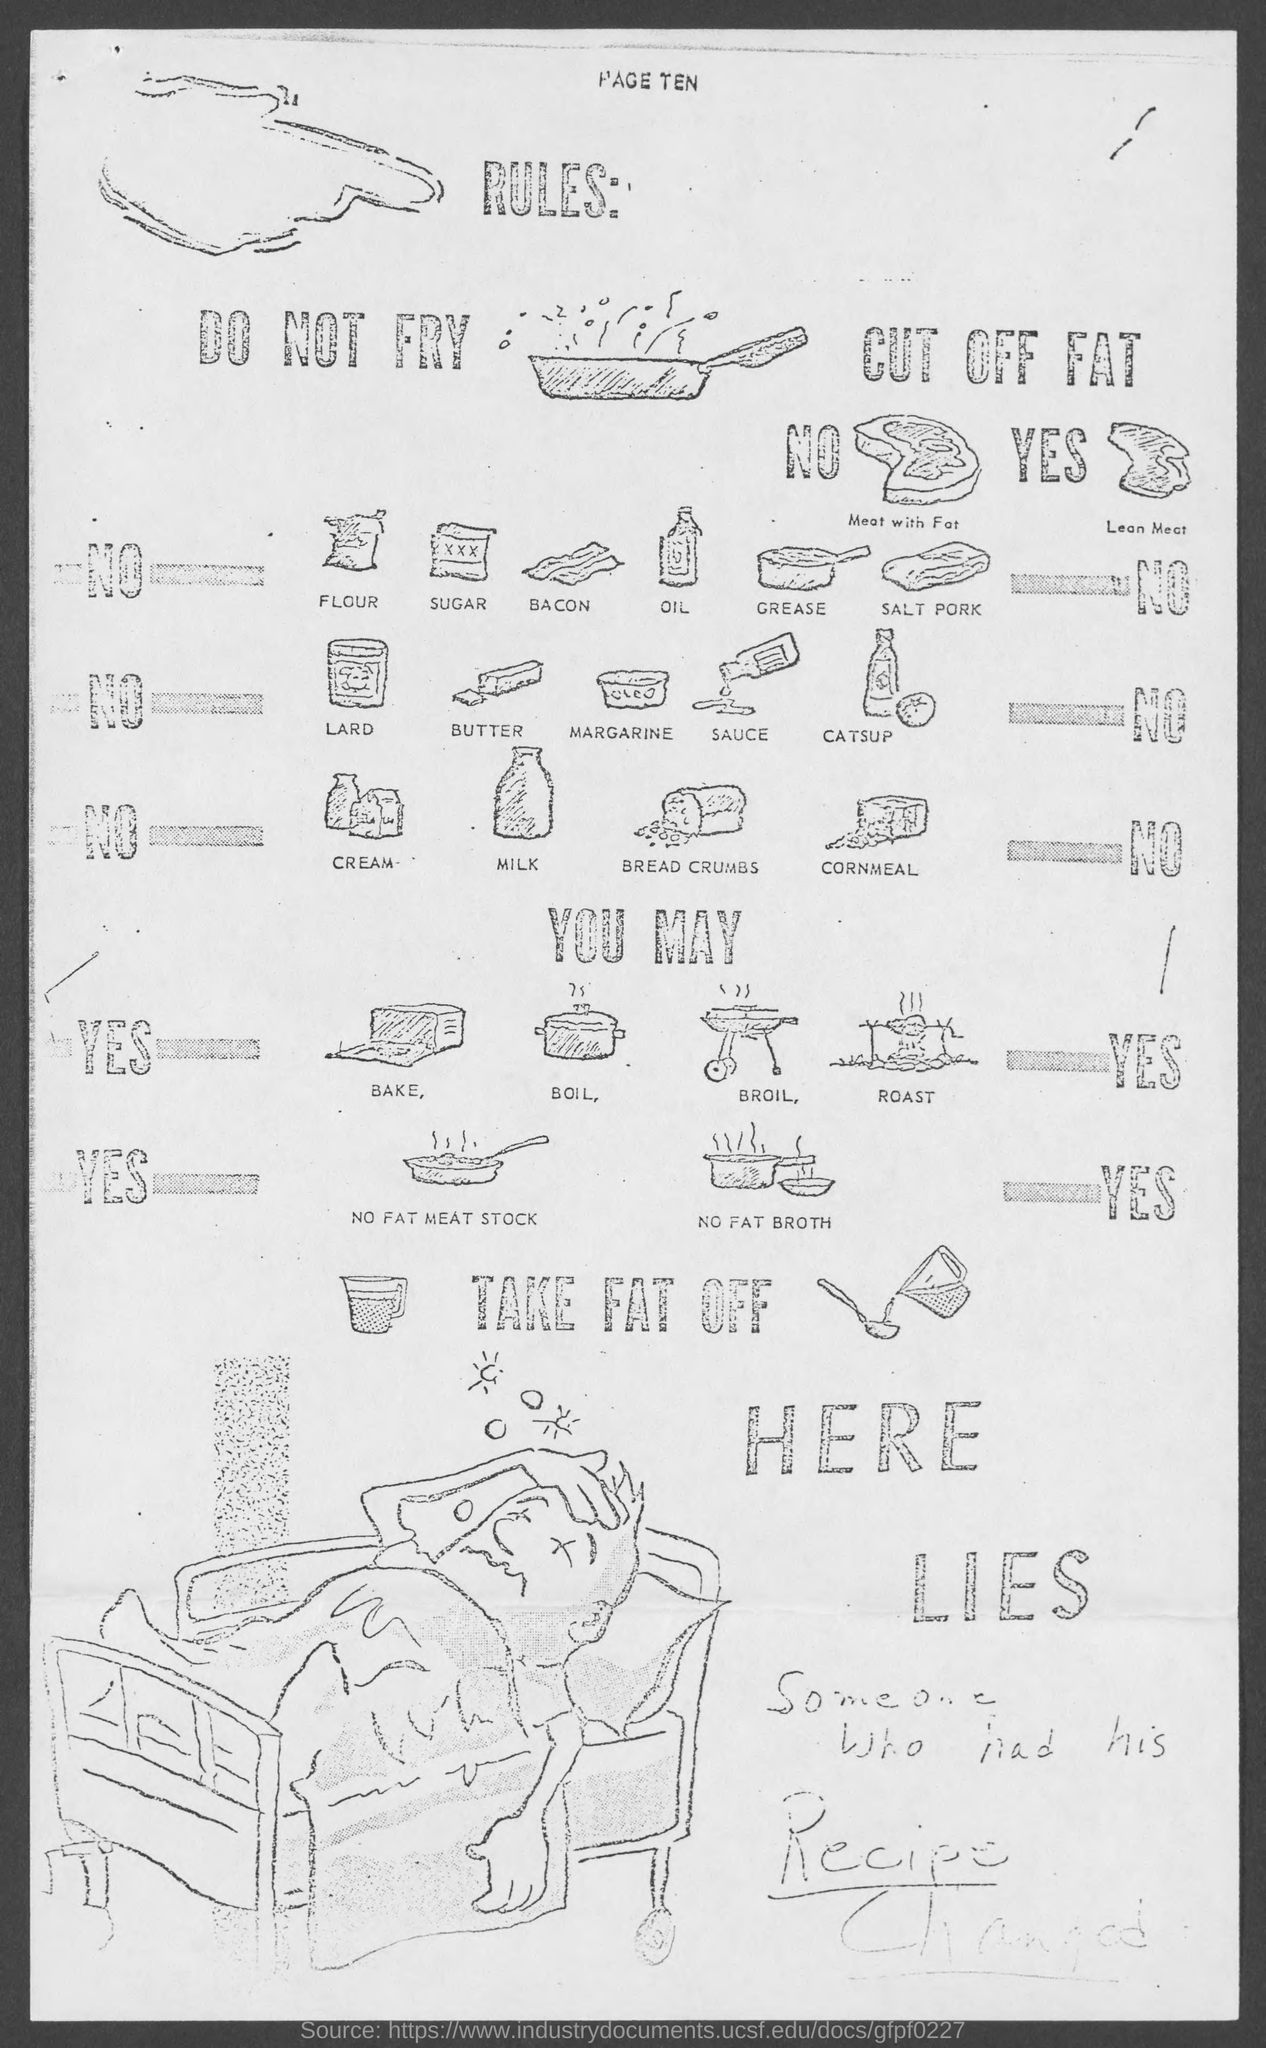What is the page no mentioned in this document?
Provide a short and direct response. PAGE TEN. 